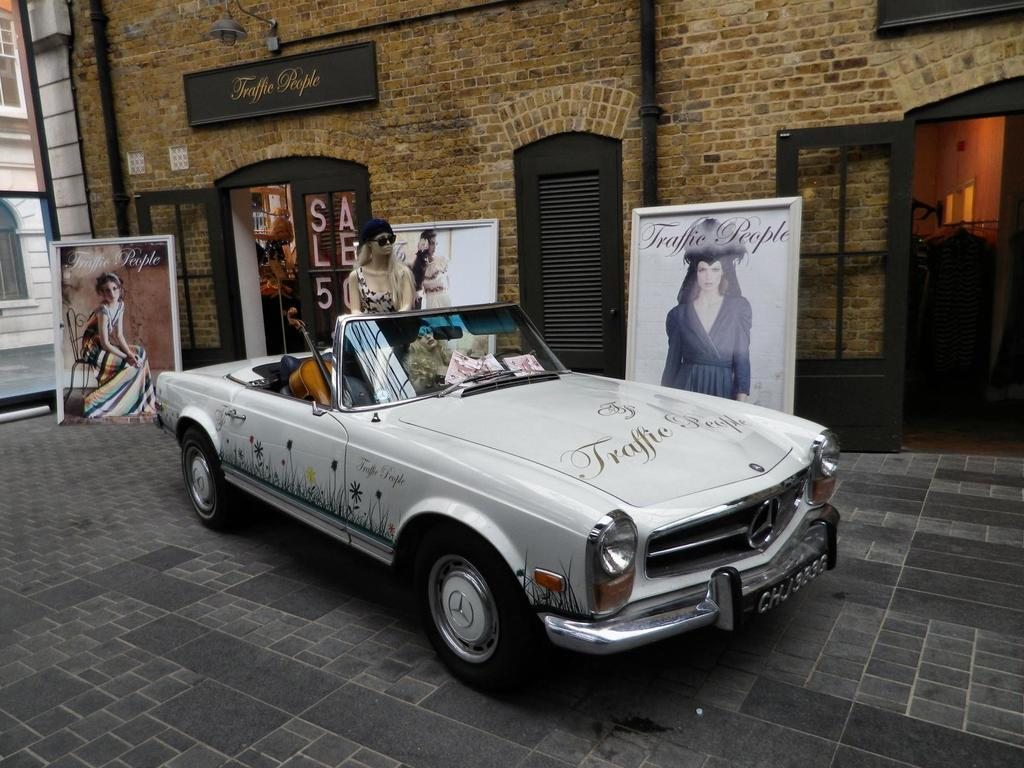What type of structure is visible in the image? There is a building in the image. Can you describe a specific feature of the building? There is a door in the image. What additional object can be seen in the image? There is a banner in the image. Who is present in the image? There is a woman standing in the image. What mode of transportation is visible in the image? There is a car in the image. What item can be seen inside the car? There is a guitar in the car. How many kittens are playing with the guitar in the car? There are no kittens present in the image, and therefore no such activity can be observed. What type of crow is perched on the banner in the image? There is no crow present in the image; only the banner, building, door, woman, car, and guitar are visible. 